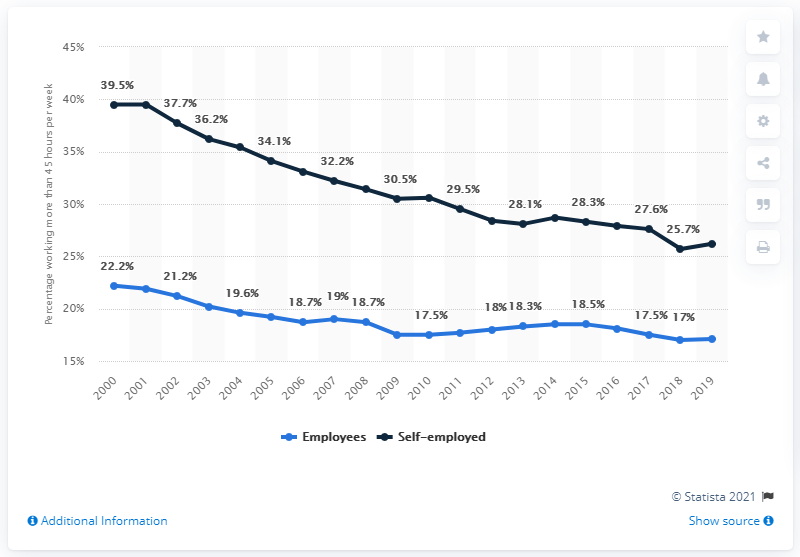Outline some significant characteristics in this image. It is the case that the order of employees within a group is consistently decreasing. The sum of 2018 is 42.7 and other numbers. 